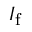<formula> <loc_0><loc_0><loc_500><loc_500>I _ { f }</formula> 